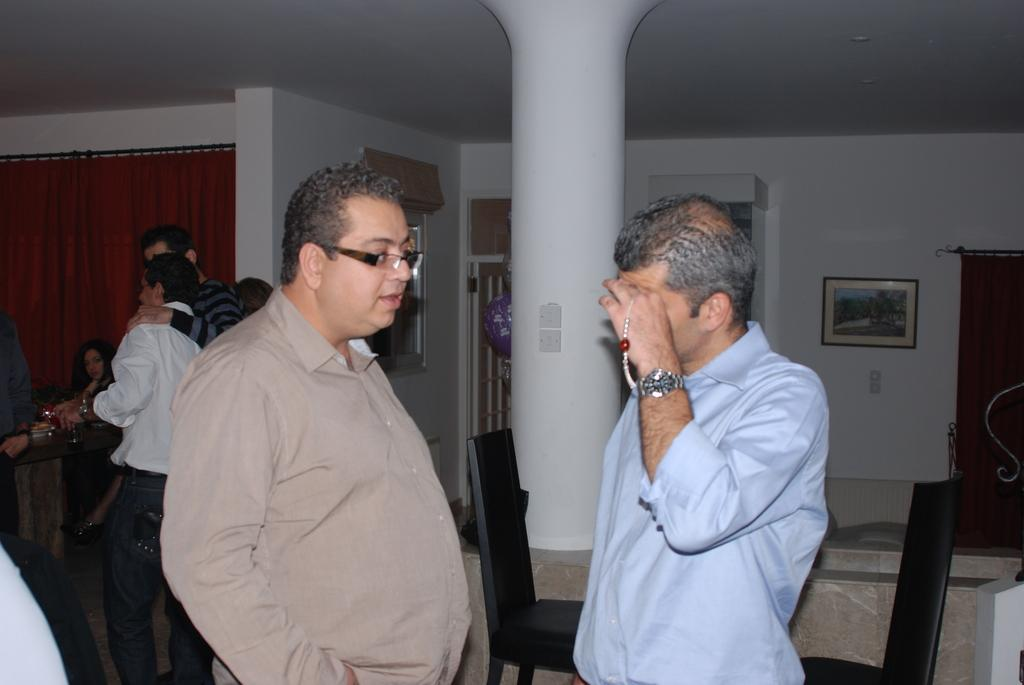How many people are in the image? There are people in the image, and most of them are men. What can be seen on the left side of the side of the image? There is a red color curtain on the left side of the image. What is present on the wall in the background of the image? There is a photo frame on the wall in the background of the image. In which direction are the people in the image wishing to travel? The image does not provide information about the direction in which the people wish to travel, nor does it mention any wishes or desires of the people. 